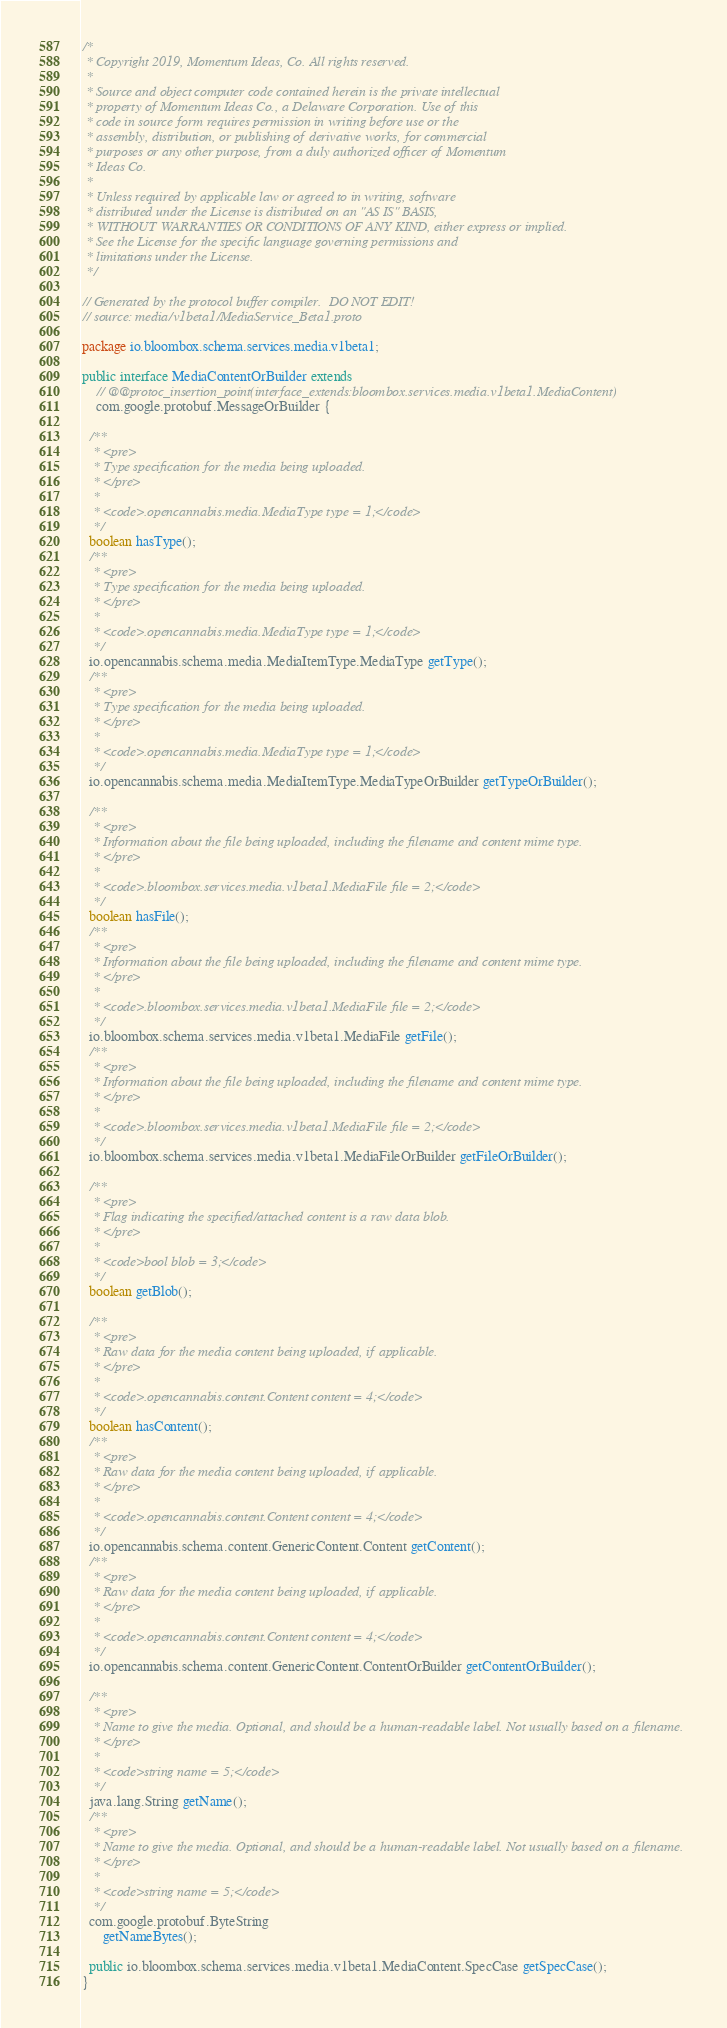Convert code to text. <code><loc_0><loc_0><loc_500><loc_500><_Java_>/*
 * Copyright 2019, Momentum Ideas, Co. All rights reserved.
 *
 * Source and object computer code contained herein is the private intellectual
 * property of Momentum Ideas Co., a Delaware Corporation. Use of this
 * code in source form requires permission in writing before use or the
 * assembly, distribution, or publishing of derivative works, for commercial
 * purposes or any other purpose, from a duly authorized officer of Momentum
 * Ideas Co.
 *
 * Unless required by applicable law or agreed to in writing, software
 * distributed under the License is distributed on an "AS IS" BASIS,
 * WITHOUT WARRANTIES OR CONDITIONS OF ANY KIND, either express or implied.
 * See the License for the specific language governing permissions and
 * limitations under the License.
 */

// Generated by the protocol buffer compiler.  DO NOT EDIT!
// source: media/v1beta1/MediaService_Beta1.proto

package io.bloombox.schema.services.media.v1beta1;

public interface MediaContentOrBuilder extends
    // @@protoc_insertion_point(interface_extends:bloombox.services.media.v1beta1.MediaContent)
    com.google.protobuf.MessageOrBuilder {

  /**
   * <pre>
   * Type specification for the media being uploaded.
   * </pre>
   *
   * <code>.opencannabis.media.MediaType type = 1;</code>
   */
  boolean hasType();
  /**
   * <pre>
   * Type specification for the media being uploaded.
   * </pre>
   *
   * <code>.opencannabis.media.MediaType type = 1;</code>
   */
  io.opencannabis.schema.media.MediaItemType.MediaType getType();
  /**
   * <pre>
   * Type specification for the media being uploaded.
   * </pre>
   *
   * <code>.opencannabis.media.MediaType type = 1;</code>
   */
  io.opencannabis.schema.media.MediaItemType.MediaTypeOrBuilder getTypeOrBuilder();

  /**
   * <pre>
   * Information about the file being uploaded, including the filename and content mime type.
   * </pre>
   *
   * <code>.bloombox.services.media.v1beta1.MediaFile file = 2;</code>
   */
  boolean hasFile();
  /**
   * <pre>
   * Information about the file being uploaded, including the filename and content mime type.
   * </pre>
   *
   * <code>.bloombox.services.media.v1beta1.MediaFile file = 2;</code>
   */
  io.bloombox.schema.services.media.v1beta1.MediaFile getFile();
  /**
   * <pre>
   * Information about the file being uploaded, including the filename and content mime type.
   * </pre>
   *
   * <code>.bloombox.services.media.v1beta1.MediaFile file = 2;</code>
   */
  io.bloombox.schema.services.media.v1beta1.MediaFileOrBuilder getFileOrBuilder();

  /**
   * <pre>
   * Flag indicating the specified/attached content is a raw data blob.
   * </pre>
   *
   * <code>bool blob = 3;</code>
   */
  boolean getBlob();

  /**
   * <pre>
   * Raw data for the media content being uploaded, if applicable.
   * </pre>
   *
   * <code>.opencannabis.content.Content content = 4;</code>
   */
  boolean hasContent();
  /**
   * <pre>
   * Raw data for the media content being uploaded, if applicable.
   * </pre>
   *
   * <code>.opencannabis.content.Content content = 4;</code>
   */
  io.opencannabis.schema.content.GenericContent.Content getContent();
  /**
   * <pre>
   * Raw data for the media content being uploaded, if applicable.
   * </pre>
   *
   * <code>.opencannabis.content.Content content = 4;</code>
   */
  io.opencannabis.schema.content.GenericContent.ContentOrBuilder getContentOrBuilder();

  /**
   * <pre>
   * Name to give the media. Optional, and should be a human-readable label. Not usually based on a filename.
   * </pre>
   *
   * <code>string name = 5;</code>
   */
  java.lang.String getName();
  /**
   * <pre>
   * Name to give the media. Optional, and should be a human-readable label. Not usually based on a filename.
   * </pre>
   *
   * <code>string name = 5;</code>
   */
  com.google.protobuf.ByteString
      getNameBytes();

  public io.bloombox.schema.services.media.v1beta1.MediaContent.SpecCase getSpecCase();
}
</code> 